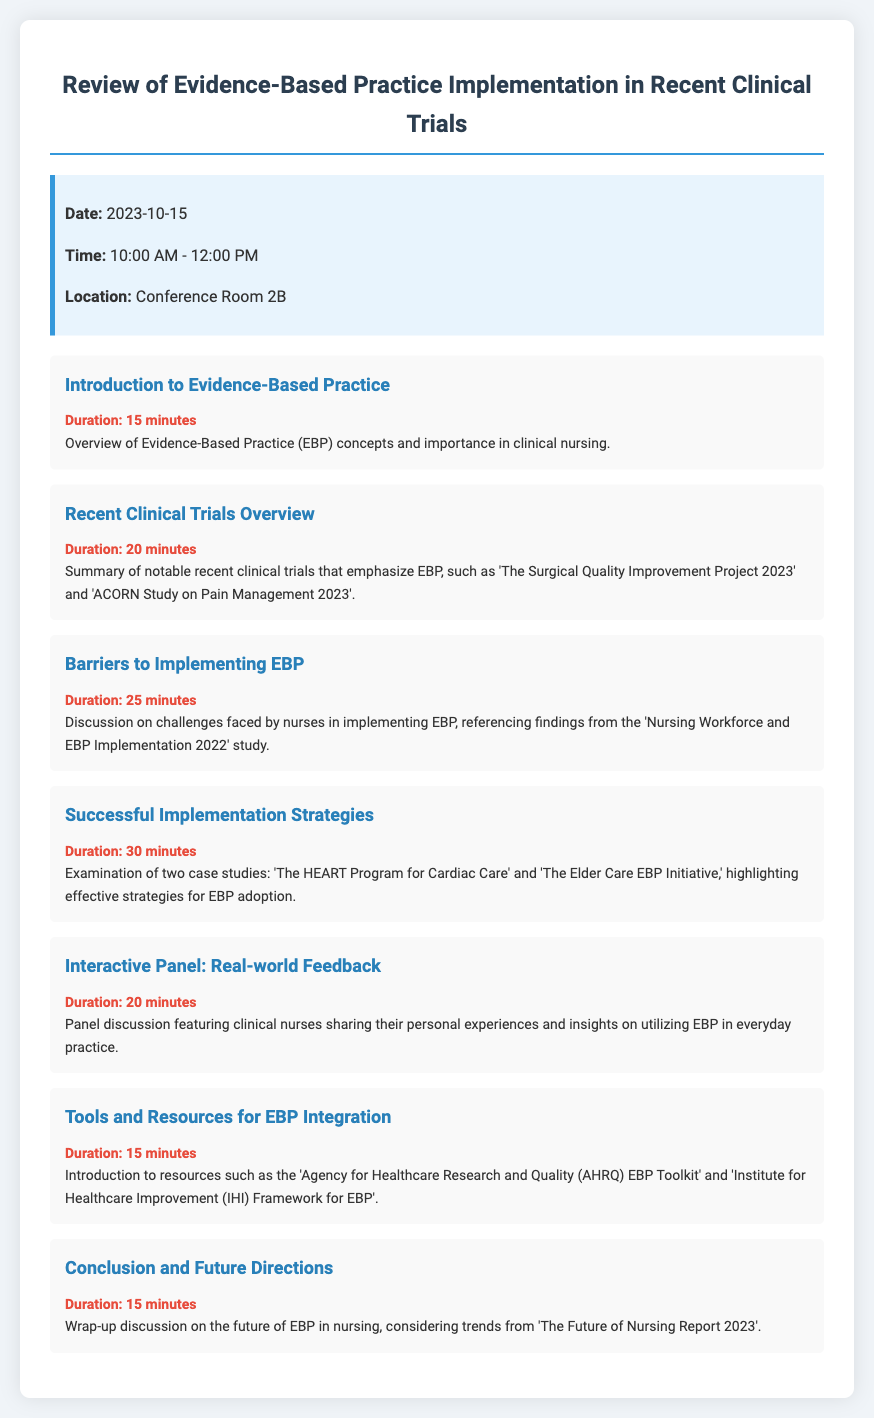what is the date of the event? The date of the event is provided in the info section of the document.
Answer: 2023-10-15 what time does the event start? The start time of the event is listed under the info section.
Answer: 10:00 AM how long is the session on barriers to implementing EBP? The duration of the session on barriers to implementing EBP is stated in the agenda item.
Answer: 25 minutes which trial is mentioned in the recent clinical trials overview? The document mentions notable clinical trials in the recent overview section.
Answer: The Surgical Quality Improvement Project 2023 what is the main topic of the interactive panel? The main topic of the interactive panel is described in the respective agenda item.
Answer: Real-world Feedback name one resource introduced for EBP integration. The document lists various resources for EBP integration.
Answer: AHRQ EBP Toolkit how many total minutes are allocated for the conclusion? The duration of the conclusion is provided in the agenda item; summing requires just that individual item.
Answer: 15 minutes what is the focus of the successful implementation strategies session? The focus of the successful implementation strategies is summarized in the agenda item overview.
Answer: Effective strategies for EBP adoption which study's findings are referenced regarding barriers to EBP? The document specifically mentions a study that focuses on barriers in the respective section.
Answer: Nursing Workforce and EBP Implementation 2022 